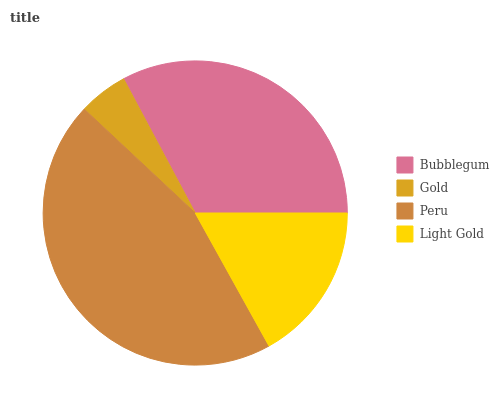Is Gold the minimum?
Answer yes or no. Yes. Is Peru the maximum?
Answer yes or no. Yes. Is Peru the minimum?
Answer yes or no. No. Is Gold the maximum?
Answer yes or no. No. Is Peru greater than Gold?
Answer yes or no. Yes. Is Gold less than Peru?
Answer yes or no. Yes. Is Gold greater than Peru?
Answer yes or no. No. Is Peru less than Gold?
Answer yes or no. No. Is Bubblegum the high median?
Answer yes or no. Yes. Is Light Gold the low median?
Answer yes or no. Yes. Is Light Gold the high median?
Answer yes or no. No. Is Bubblegum the low median?
Answer yes or no. No. 